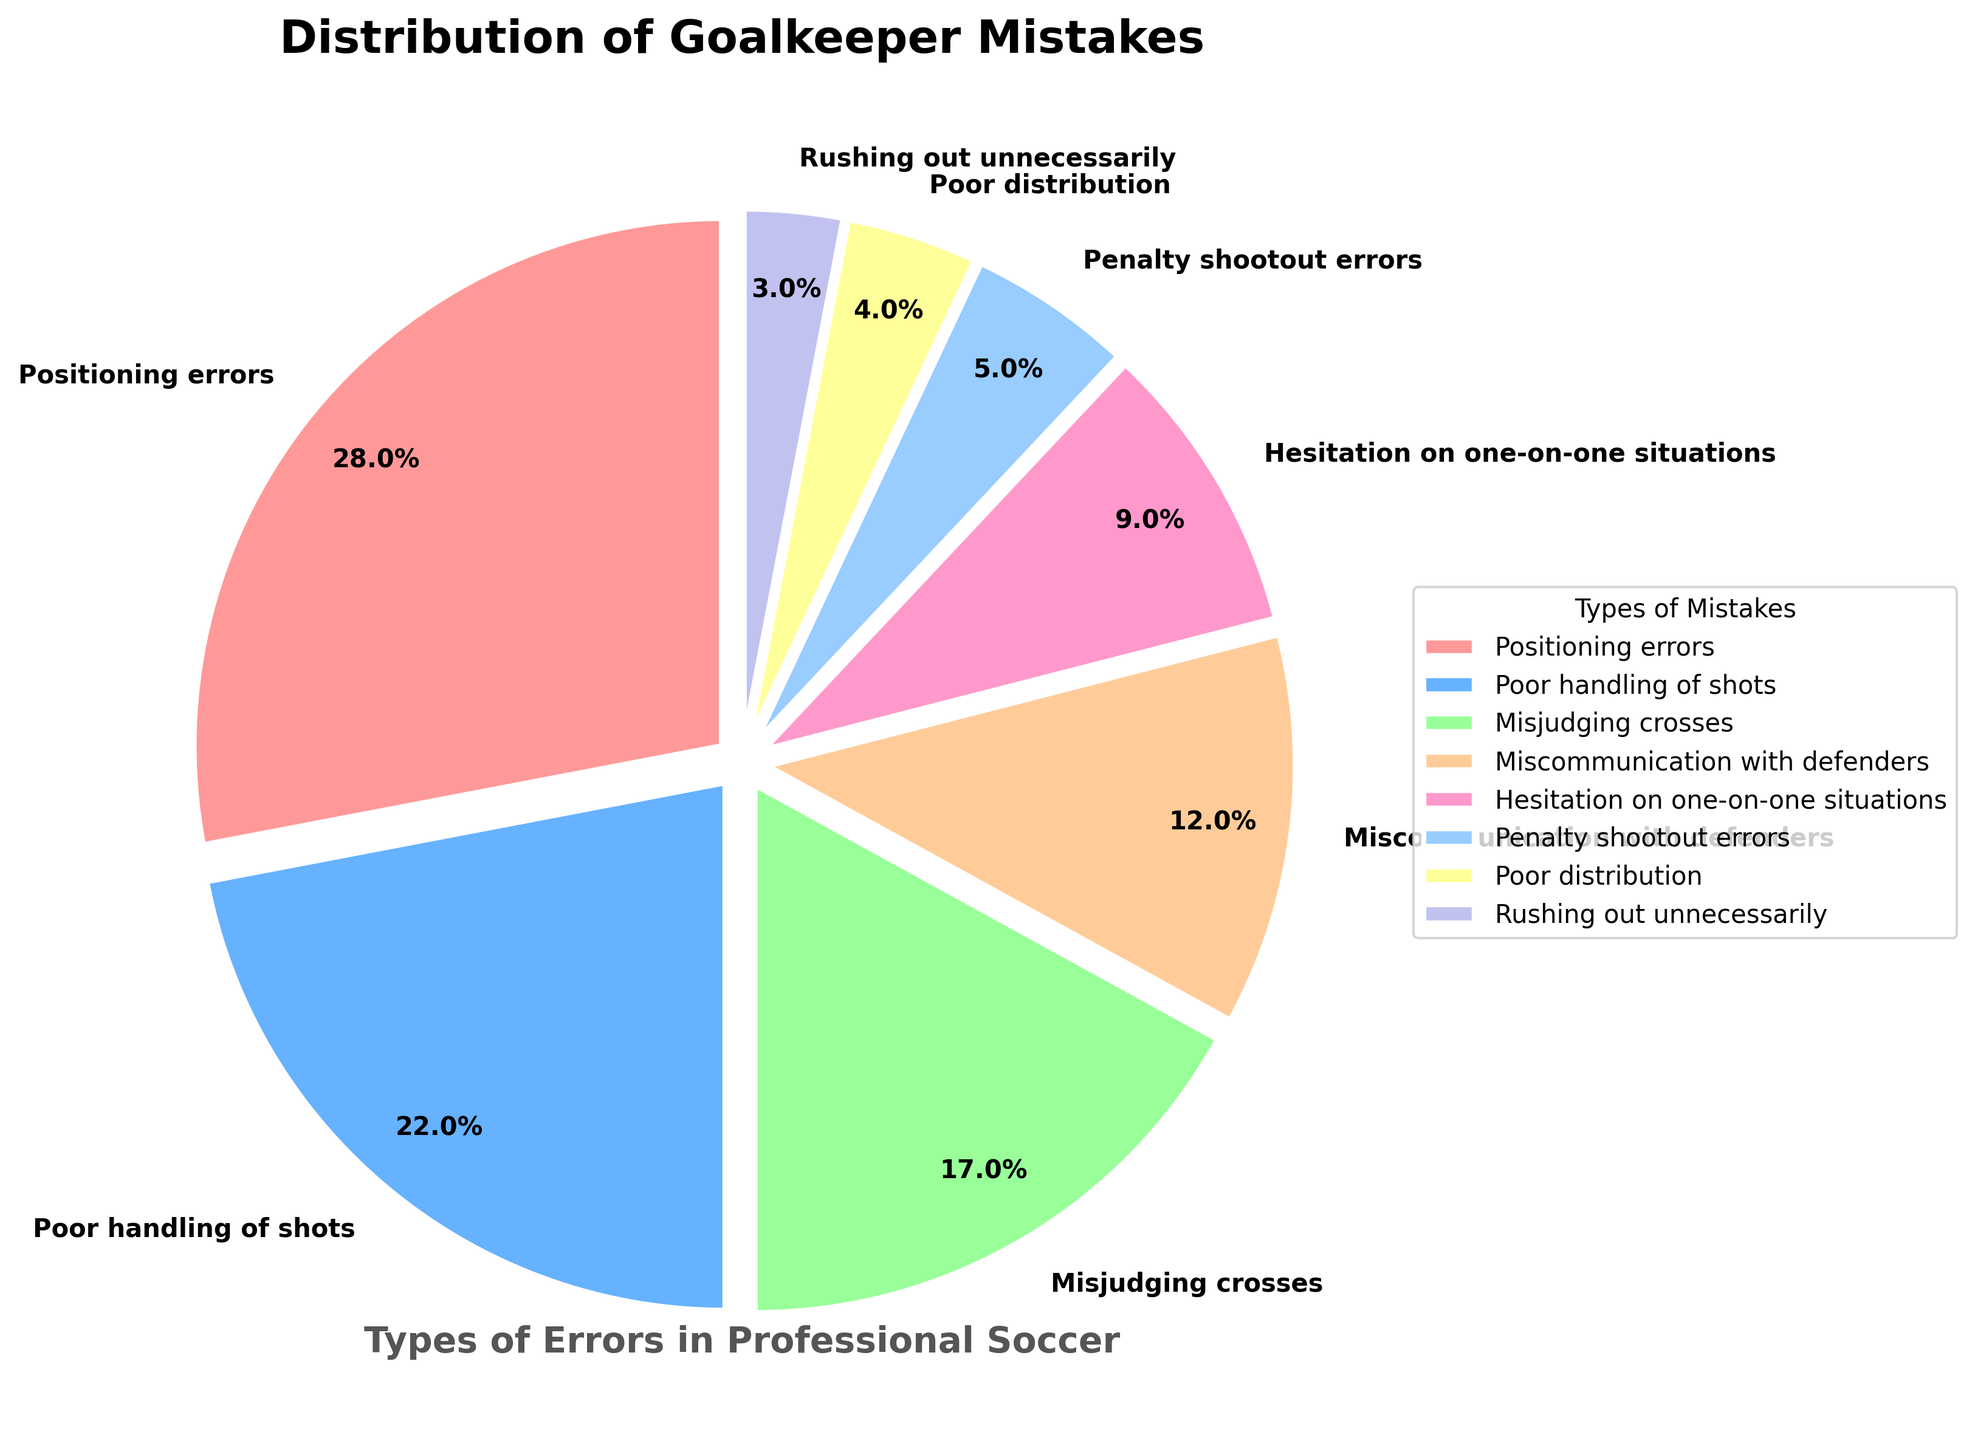Which type of mistake accounts for the largest percentage of goalkeeper mistakes? The pie chart shows different segments representing various types of mistakes with their respective percentages. The largest segment is for "Positioning errors" at 28%.
Answer: Positioning errors Which mistakes together account for more than half of the total percentage? Summing up the percentages of each mistake from largest to smallest: "Positioning errors" (28%) + "Poor handling of shots" (22%) = 50%, and since it's already more than half, just these two combined account for more than 50%.
Answer: Positioning errors and Poor handling of shots What is the difference in percentage between "Misjudging crosses" and "Miscommunication with defenders"? "Misjudging crosses" is at 17% and "Miscommunication with defenders" is at 12%. The difference is calculated as 17% - 12% = 5%.
Answer: 5% Are penalty shootout errors more or less common than rushing out unnecessarily? The pie chart shows "Penalty shootout errors" at 5% and "Rushing out unnecessarily" at 3%. Since 5% is greater than 3%, penalty shootout errors are more common.
Answer: More common What is the combined percentage of "Hesitation on one-on-one situations" and "Poor distribution"? The pie chart lists "Hesitation on one-on-one situations" as 9% and "Poor distribution" as 4%. Summing them gives 9% + 4% = 13%.
Answer: 13% Which type of mistake has the smallest percentage? The smallest segment in the pie chart corresponds to "Rushing out unnecessarily," which is 3%.
Answer: Rushing out unnecessarily What percentage of mistakes is contributed by "Miscommunication with defenders" and "Hesitation on one-on-one situations" combined? The percentages for "Miscommunication with defenders" (12%) and "Hesitation on one-on-one situations" (9%) are summed up: 12% + 9% = 21%.
Answer: 21% By how much does "Poor handling of shots" exceed "Hesitation on one-on-one situations"? "Poor handling of shots" is 22% and "Hesitation on one-on-one situations" is 9%. The difference between them is calculated as 22% - 9% = 13%.
Answer: 13% Which mistake category has exactly 12% contribution? The pie chart specifies "Miscommunication with defenders" as the category with exactly 12%.
Answer: Miscommunication with defenders 